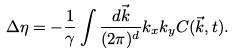<formula> <loc_0><loc_0><loc_500><loc_500>\Delta \eta = - \frac { 1 } { \gamma } \int \frac { d \vec { k } } { ( 2 \pi ) ^ { d } } k _ { x } k _ { y } C ( \vec { k } , t ) .</formula> 